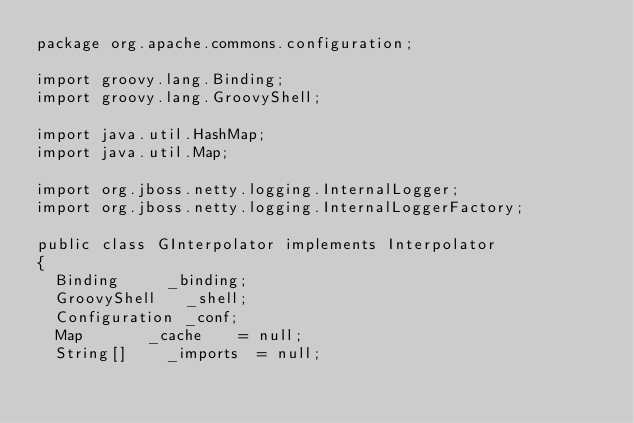Convert code to text. <code><loc_0><loc_0><loc_500><loc_500><_Java_>package org.apache.commons.configuration;

import groovy.lang.Binding;
import groovy.lang.GroovyShell;

import java.util.HashMap;
import java.util.Map;

import org.jboss.netty.logging.InternalLogger;
import org.jboss.netty.logging.InternalLoggerFactory;

public class GInterpolator implements Interpolator
{
	Binding			_binding;
	GroovyShell		_shell;
	Configuration	_conf;
	Map				_cache		= null;
	String[]		_imports	= null;</code> 